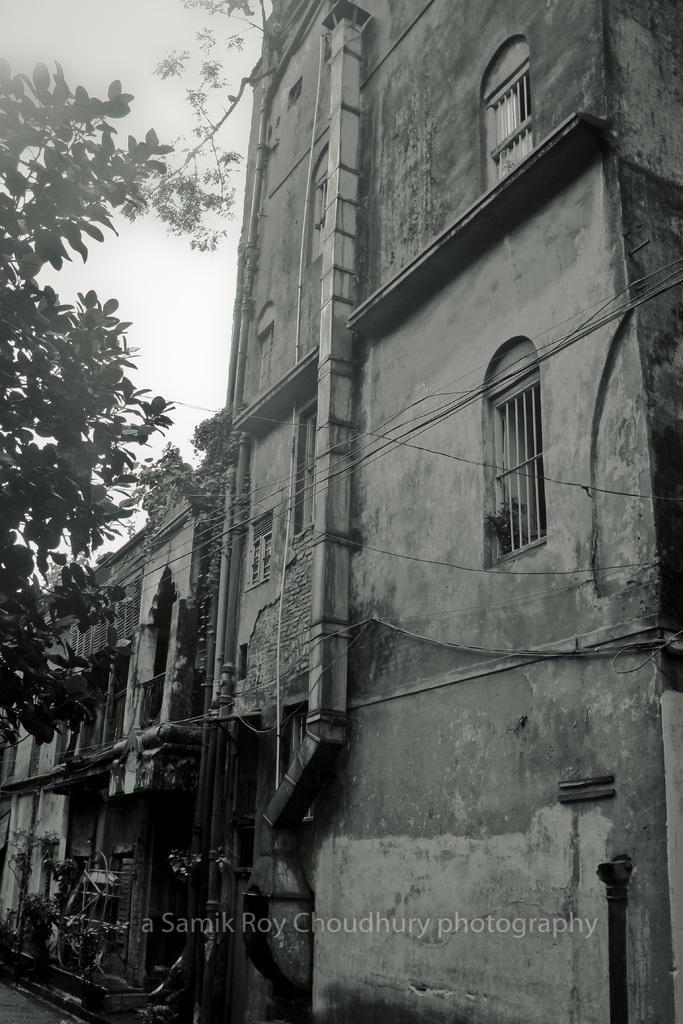Could you give a brief overview of what you see in this image? The picture is clicked outside. On the right we can see the buildings, windows of the buildings. On the left we can see the tree. In the background we can see the sky. In the foreground we can see some objects. At the bottom there is a text on the image. 